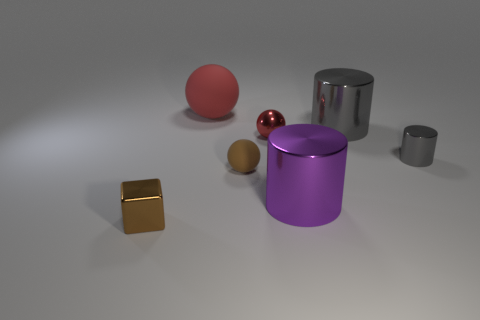Subtract all small brown balls. How many balls are left? 2 Add 1 yellow metallic objects. How many objects exist? 8 Subtract all purple cylinders. How many cylinders are left? 2 Subtract 1 blocks. How many blocks are left? 0 Subtract all yellow matte cylinders. Subtract all red spheres. How many objects are left? 5 Add 6 large purple cylinders. How many large purple cylinders are left? 7 Add 3 big red things. How many big red things exist? 4 Subtract 0 gray balls. How many objects are left? 7 Subtract all balls. How many objects are left? 4 Subtract all purple cylinders. Subtract all yellow blocks. How many cylinders are left? 2 